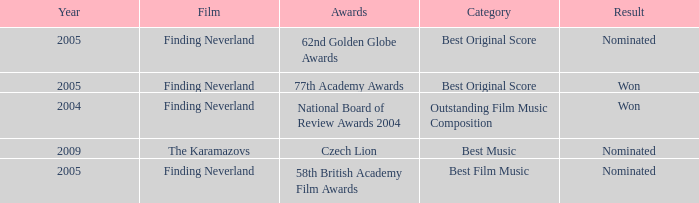Which awards happened more recently than 2005? Czech Lion. 